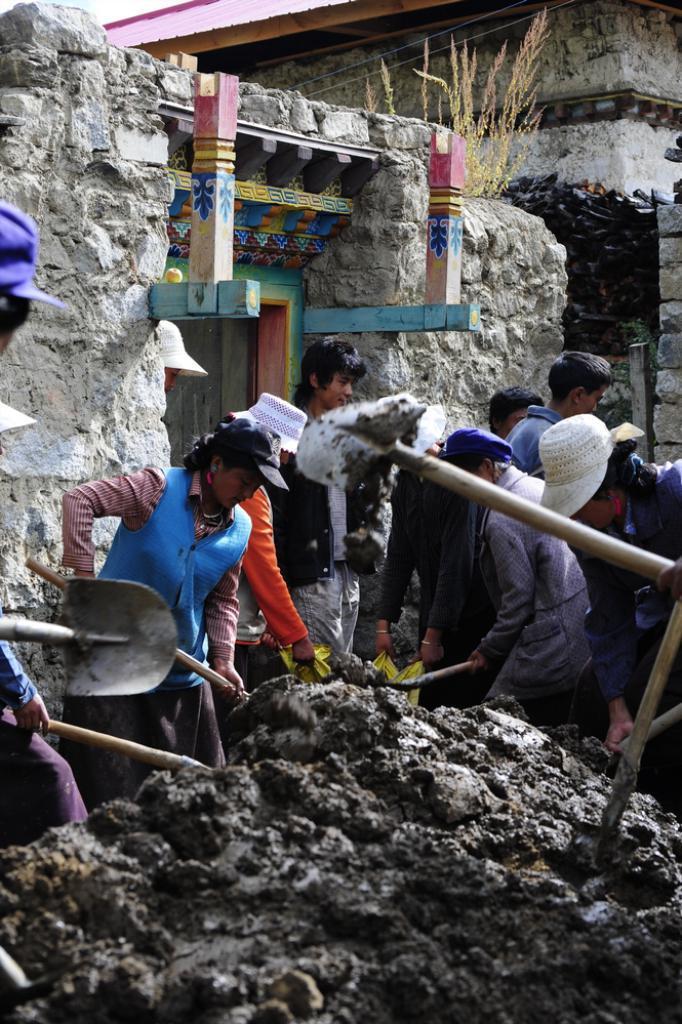Please provide a concise description of this image. In this image I can see the mud which is black in color and few persons holding mud in their hands. In the background I can see few other persons standing, the wall which is made up of rocks, the door, the building and the sky. 